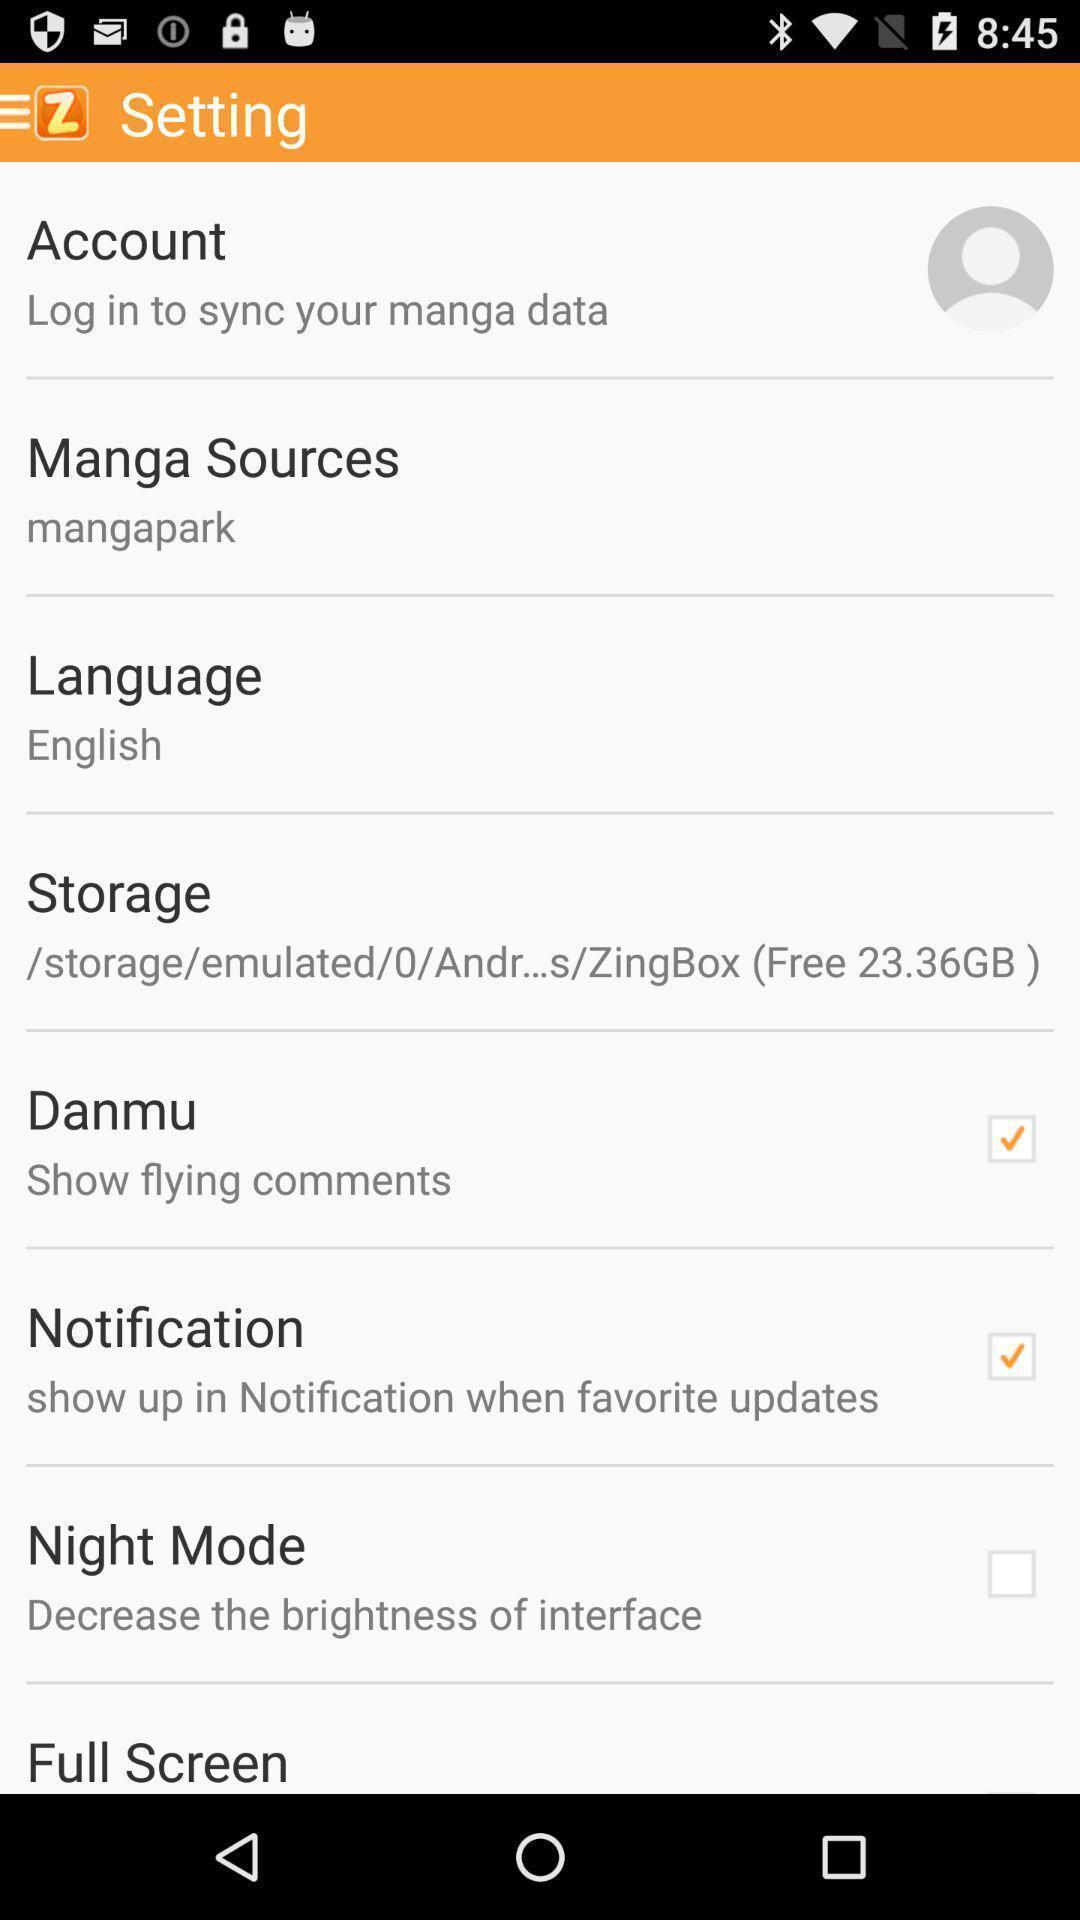Provide a description of this screenshot. Page displays settings. 